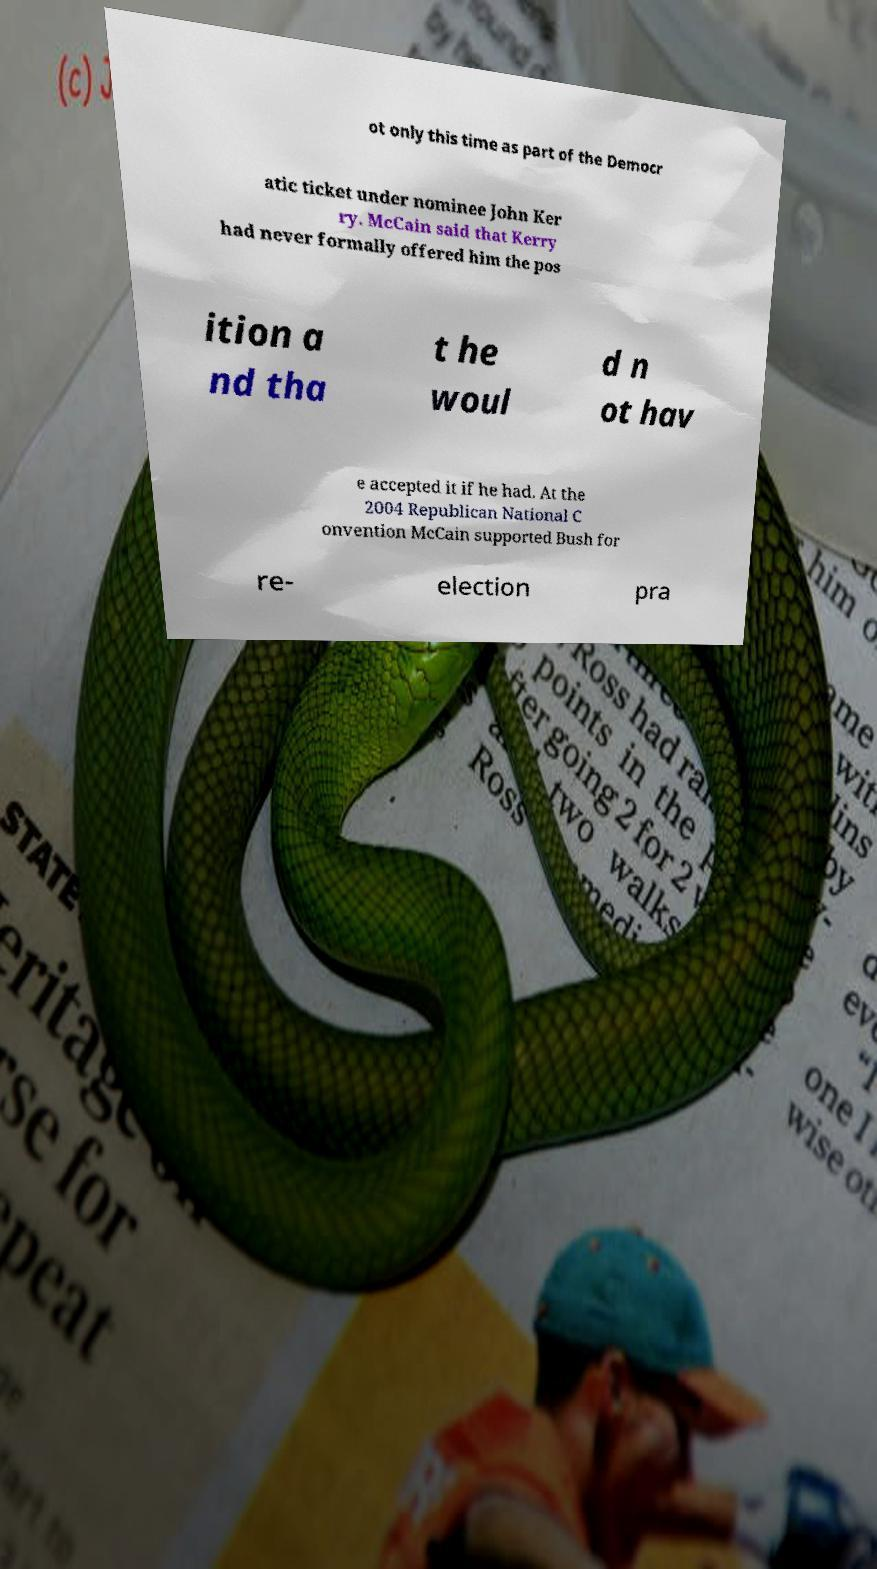Please identify and transcribe the text found in this image. ot only this time as part of the Democr atic ticket under nominee John Ker ry. McCain said that Kerry had never formally offered him the pos ition a nd tha t he woul d n ot hav e accepted it if he had. At the 2004 Republican National C onvention McCain supported Bush for re- election pra 